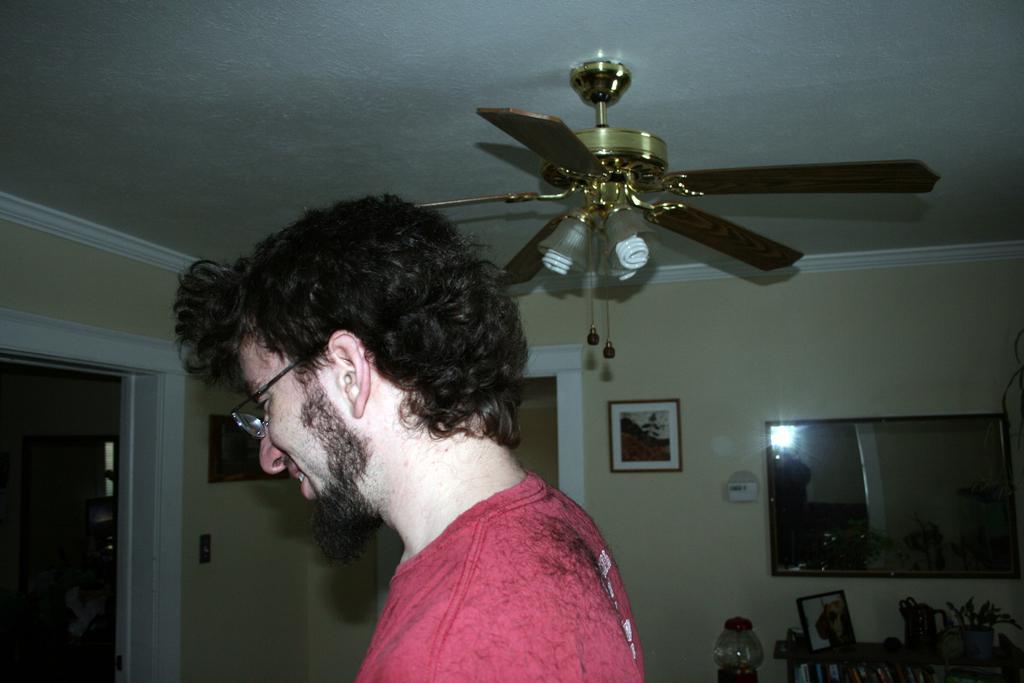Could you give a brief overview of what you see in this image? In this image there is a person wearing spectacles. Right side there is a screen and a frame attached to the wall. Right bottom there is a table having a picture frame, pot and few objects. The pot is having a plant. Left side a frame is attached to the wall having a door. Behind there are objects. Top of the image there is a fan attached to the roof. 